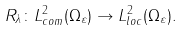Convert formula to latex. <formula><loc_0><loc_0><loc_500><loc_500>R _ { \lambda } \colon L _ { c o m } ^ { 2 } ( \Omega _ { \varepsilon } ) \rightarrow L _ { l o c } ^ { 2 } ( \Omega _ { \varepsilon } ) .</formula> 